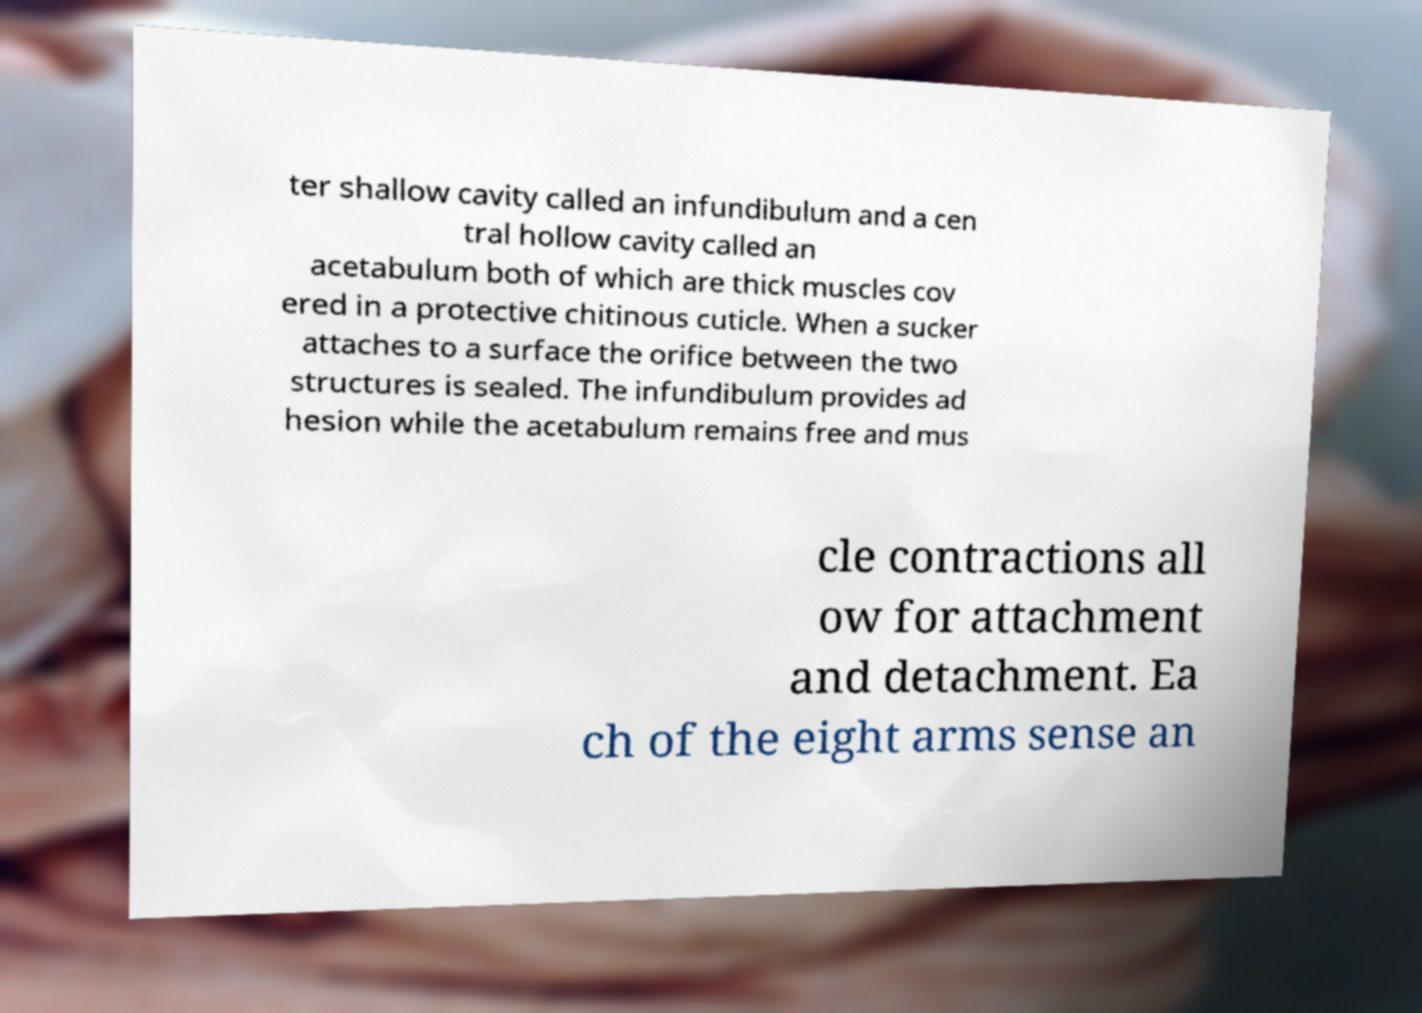Can you read and provide the text displayed in the image?This photo seems to have some interesting text. Can you extract and type it out for me? ter shallow cavity called an infundibulum and a cen tral hollow cavity called an acetabulum both of which are thick muscles cov ered in a protective chitinous cuticle. When a sucker attaches to a surface the orifice between the two structures is sealed. The infundibulum provides ad hesion while the acetabulum remains free and mus cle contractions all ow for attachment and detachment. Ea ch of the eight arms sense an 